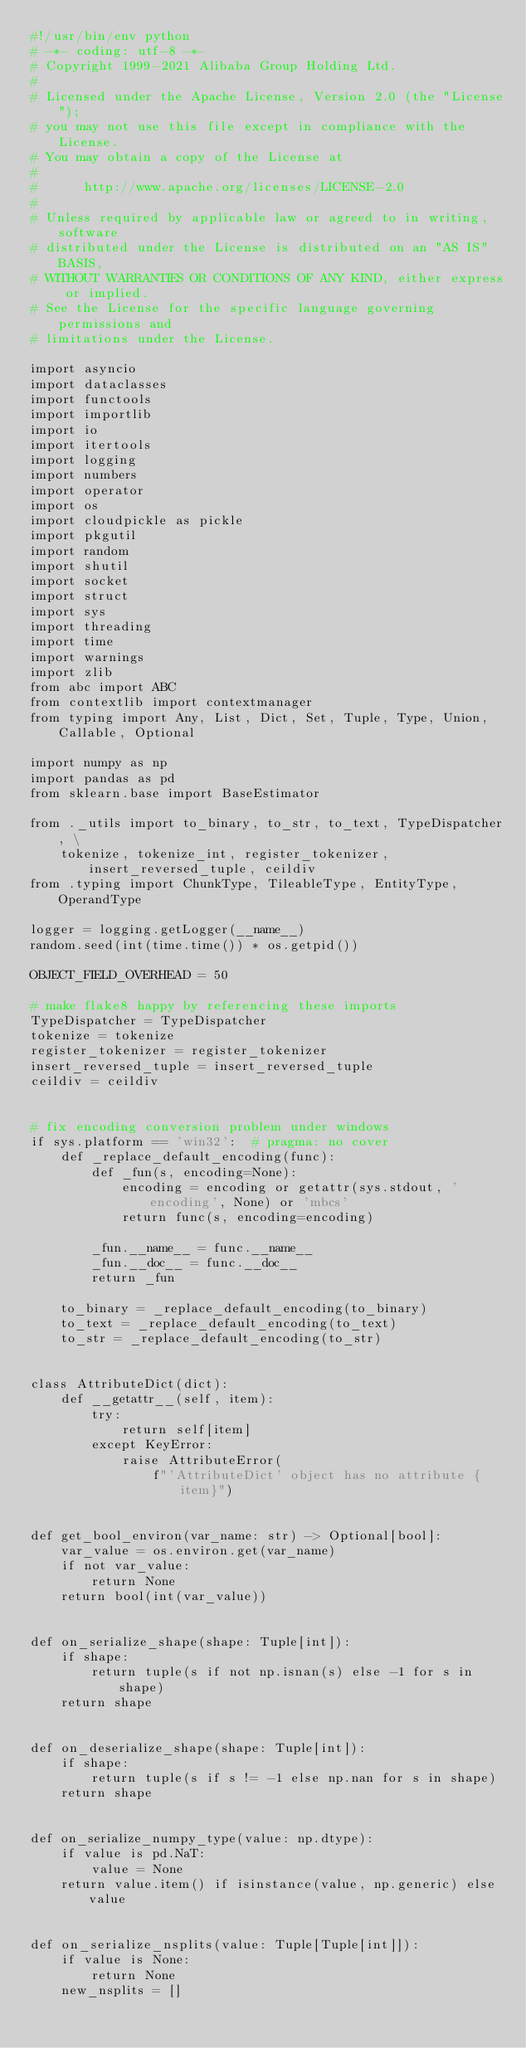Convert code to text. <code><loc_0><loc_0><loc_500><loc_500><_Python_>#!/usr/bin/env python
# -*- coding: utf-8 -*-
# Copyright 1999-2021 Alibaba Group Holding Ltd.
#
# Licensed under the Apache License, Version 2.0 (the "License");
# you may not use this file except in compliance with the License.
# You may obtain a copy of the License at
#
#      http://www.apache.org/licenses/LICENSE-2.0
#
# Unless required by applicable law or agreed to in writing, software
# distributed under the License is distributed on an "AS IS" BASIS,
# WITHOUT WARRANTIES OR CONDITIONS OF ANY KIND, either express or implied.
# See the License for the specific language governing permissions and
# limitations under the License.

import asyncio
import dataclasses
import functools
import importlib
import io
import itertools
import logging
import numbers
import operator
import os
import cloudpickle as pickle
import pkgutil
import random
import shutil
import socket
import struct
import sys
import threading
import time
import warnings
import zlib
from abc import ABC
from contextlib import contextmanager
from typing import Any, List, Dict, Set, Tuple, Type, Union, Callable, Optional

import numpy as np
import pandas as pd
from sklearn.base import BaseEstimator

from ._utils import to_binary, to_str, to_text, TypeDispatcher, \
    tokenize, tokenize_int, register_tokenizer, insert_reversed_tuple, ceildiv
from .typing import ChunkType, TileableType, EntityType, OperandType

logger = logging.getLogger(__name__)
random.seed(int(time.time()) * os.getpid())

OBJECT_FIELD_OVERHEAD = 50

# make flake8 happy by referencing these imports
TypeDispatcher = TypeDispatcher
tokenize = tokenize
register_tokenizer = register_tokenizer
insert_reversed_tuple = insert_reversed_tuple
ceildiv = ceildiv


# fix encoding conversion problem under windows
if sys.platform == 'win32':  # pragma: no cover
    def _replace_default_encoding(func):
        def _fun(s, encoding=None):
            encoding = encoding or getattr(sys.stdout, 'encoding', None) or 'mbcs'
            return func(s, encoding=encoding)

        _fun.__name__ = func.__name__
        _fun.__doc__ = func.__doc__
        return _fun

    to_binary = _replace_default_encoding(to_binary)
    to_text = _replace_default_encoding(to_text)
    to_str = _replace_default_encoding(to_str)


class AttributeDict(dict):
    def __getattr__(self, item):
        try:
            return self[item]
        except KeyError:
            raise AttributeError(
                f"'AttributeDict' object has no attribute {item}")


def get_bool_environ(var_name: str) -> Optional[bool]:
    var_value = os.environ.get(var_name)
    if not var_value:
        return None
    return bool(int(var_value))


def on_serialize_shape(shape: Tuple[int]):
    if shape:
        return tuple(s if not np.isnan(s) else -1 for s in shape)
    return shape


def on_deserialize_shape(shape: Tuple[int]):
    if shape:
        return tuple(s if s != -1 else np.nan for s in shape)
    return shape


def on_serialize_numpy_type(value: np.dtype):
    if value is pd.NaT:
        value = None
    return value.item() if isinstance(value, np.generic) else value


def on_serialize_nsplits(value: Tuple[Tuple[int]]):
    if value is None:
        return None
    new_nsplits = []</code> 